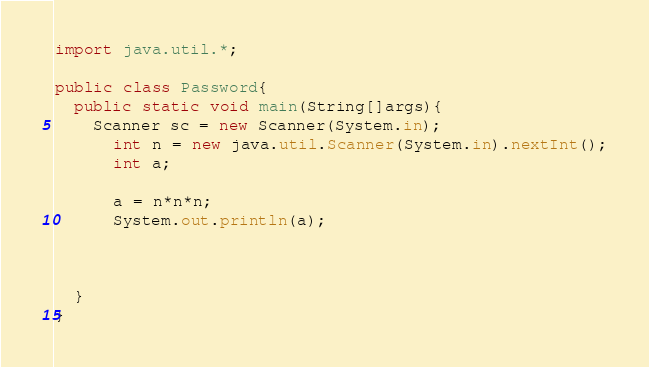Convert code to text. <code><loc_0><loc_0><loc_500><loc_500><_Java_>import java.util.*;

public class Password{
  public static void main(String[]args){
    Scanner sc = new Scanner(System.in);
      int n = new java.util.Scanner(System.in).nextInt();
      int a;

      a = n*n*n;
      System.out.println(a);



  }
}
</code> 